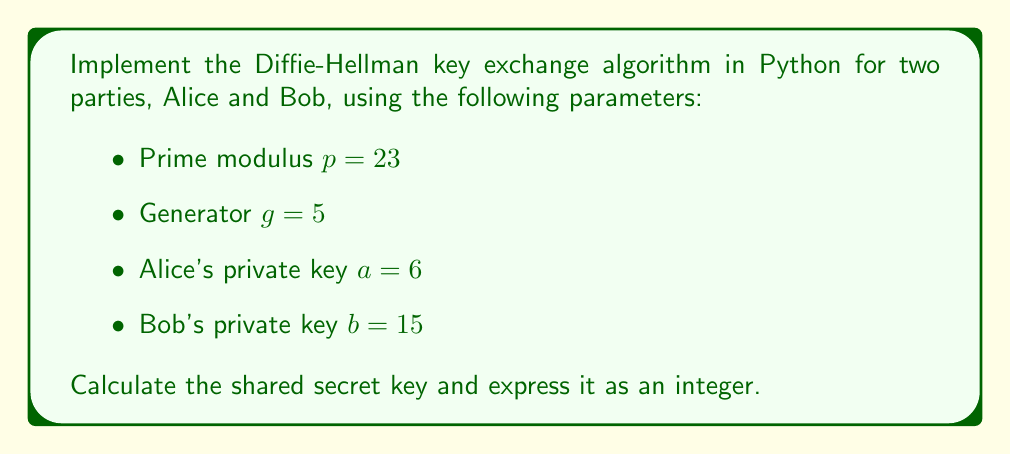Teach me how to tackle this problem. To implement the Diffie-Hellman key exchange algorithm and calculate the shared secret, we'll follow these steps:

1. Define the parameters:
   $$p = 23, g = 5, a = 6, b = 15$$

2. Calculate Alice's public key $A$:
   $$A = g^a \bmod p = 5^6 \bmod 23 = 15625 \bmod 23 = 8$$

3. Calculate Bob's public key $B$:
   $$B = g^b \bmod p = 5^{15} \bmod 23 = 30517578125 \bmod 23 = 19$$

4. Alice calculates the shared secret:
   $$s_A = B^a \bmod p = 19^6 \bmod 23 = 47045881 \bmod 23 = 2$$

5. Bob calculates the shared secret:
   $$s_B = A^b \bmod p = 8^{15} \bmod 23 = 35184372088832 \bmod 23 = 2$$

6. Verify that $s_A = s_B = 2$, which is the shared secret key.

Python implementation:

```python
def mod_pow(base, exponent, modulus):
    result = 1
    while exponent > 0:
        if exponent & 1:
            result = (result * base) % modulus
        exponent >>= 1
        base = (base * base) % modulus
    return result

p, g = 23, 5
a, b = 6, 15

A = mod_pow(g, a, p)
B = mod_pow(g, b, p)

s_A = mod_pow(B, a, p)
s_B = mod_pow(A, b, p)

print(f"Shared secret: {s_A}")
assert s_A == s_B
```

This implementation uses the efficient modular exponentiation algorithm to calculate the powers, which is crucial for larger numbers in real-world applications.
Answer: 2 